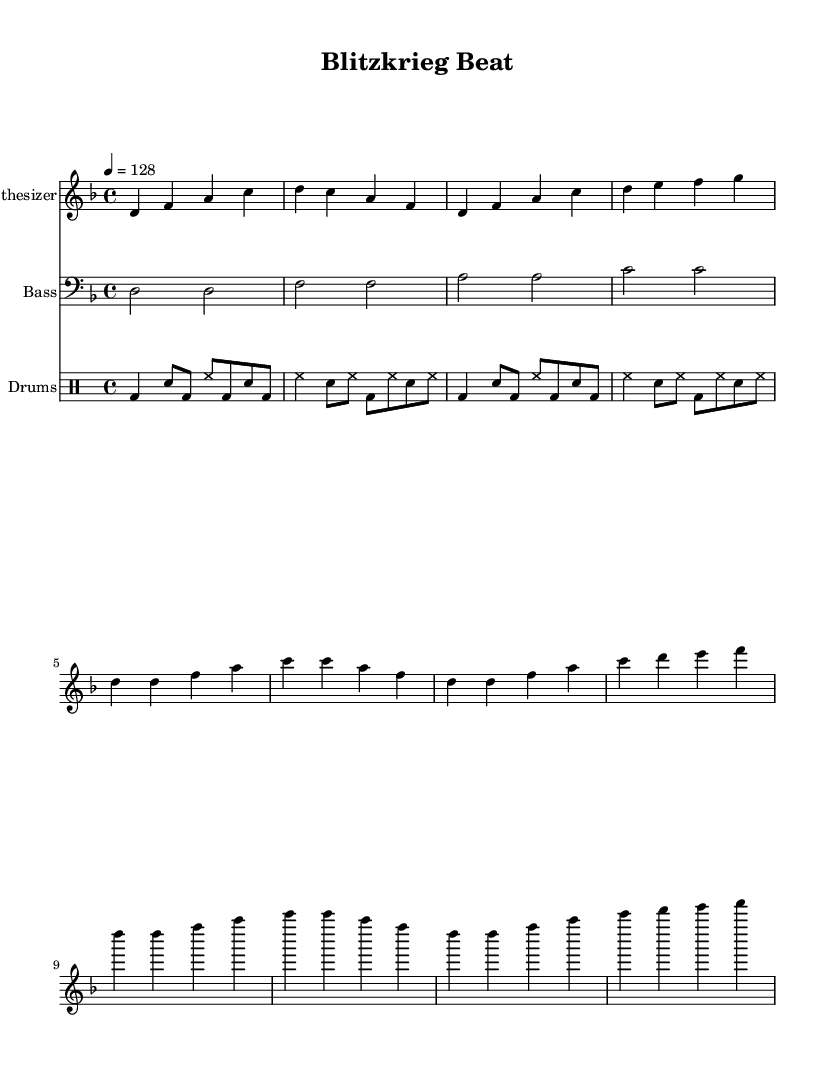What is the key signature of this music? The key signature is indicated by the presence of the flat sign on the staff, denoting D minor, which includes one flat (B flat).
Answer: D minor What is the time signature of this music? The time signature is displayed at the beginning and is indicated as 4/4, meaning there are four beats in each measure and the quarter note gets one beat.
Answer: 4/4 What is the tempo marking for this piece? The tempo marking is given as "4 = 128," which indicates the piece should be played at a speed of 128 beats per minute.
Answer: 128 How many measures does the intro section have? The intro consists of four measures, characterized by the notes and rhythmic patterns outlined at the start of the piece.
Answer: 4 What type of instrument is used for the main melodic line? The main melodic line is played by a synthesizer, as indicated in the notation with "Synthesizer" listed as the instrument name.
Answer: Synthesizer What rhythmic pattern does the drum part primarily use? The drum part primarily utilizes a pattern that consists of bass drum and snare hits in a sequence that contributes to a dance rhythm, alternating between bass drum and snare on specified beats.
Answer: Alternating bass and snare Which section contains the drop? The drop section is characterized by the repeated patterns and energetic rhythms, visually represented in the music, specifically labeled within the score as "Drop."
Answer: Drop 